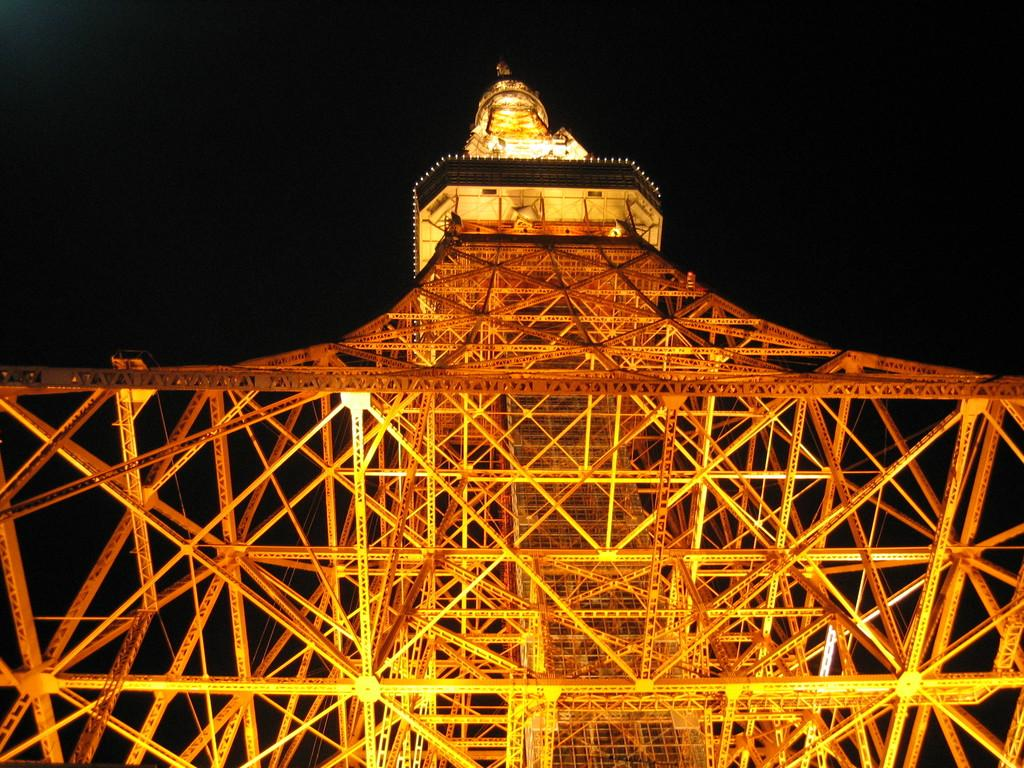What is the main subject in the center of the image? There is an Eiffel Tower in the center of the image. What can be seen in the background of the image? The sky is visible in the background of the image. What type of match is being played in the image? There is no match being played in the image; it only features the Eiffel Tower and the sky. 